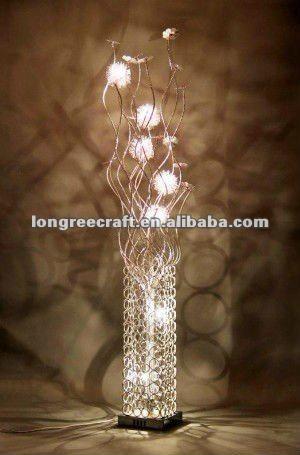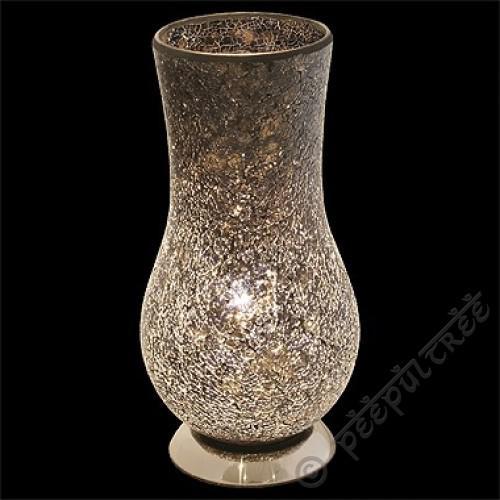The first image is the image on the left, the second image is the image on the right. For the images displayed, is the sentence "One of the two vases is glowing yellow." factually correct? Answer yes or no. No. The first image is the image on the left, the second image is the image on the right. Given the left and right images, does the statement "In at least one image  there is a white and black speckled vase with a solid black top and bottom." hold true? Answer yes or no. No. 